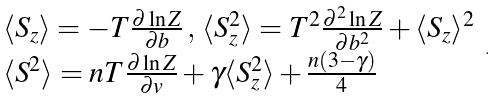<formula> <loc_0><loc_0><loc_500><loc_500>\begin{array} { l } \langle S _ { z } \rangle = - T \frac { \partial \ln Z } { \partial b } \, , \, \langle S _ { z } ^ { 2 } \rangle = T ^ { 2 } \frac { \partial ^ { 2 } \ln Z } { \partial b ^ { 2 } } + \langle S _ { z } \rangle ^ { 2 } \\ \langle S ^ { 2 } \rangle = n T \frac { \partial \ln Z } { \partial v } + \gamma \langle S _ { z } ^ { 2 } \rangle + \frac { n ( 3 - \gamma ) } { 4 } \end{array} \, .</formula> 